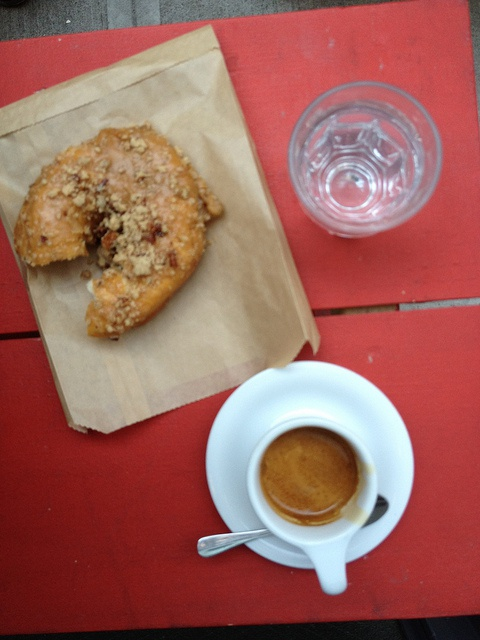Describe the objects in this image and their specific colors. I can see dining table in brown, darkgray, and maroon tones, donut in black, tan, olive, and maroon tones, cup in black, darkgray, brown, gray, and lightpink tones, cup in black, olive, lightblue, and maroon tones, and spoon in black, darkgray, gray, and lightblue tones in this image. 